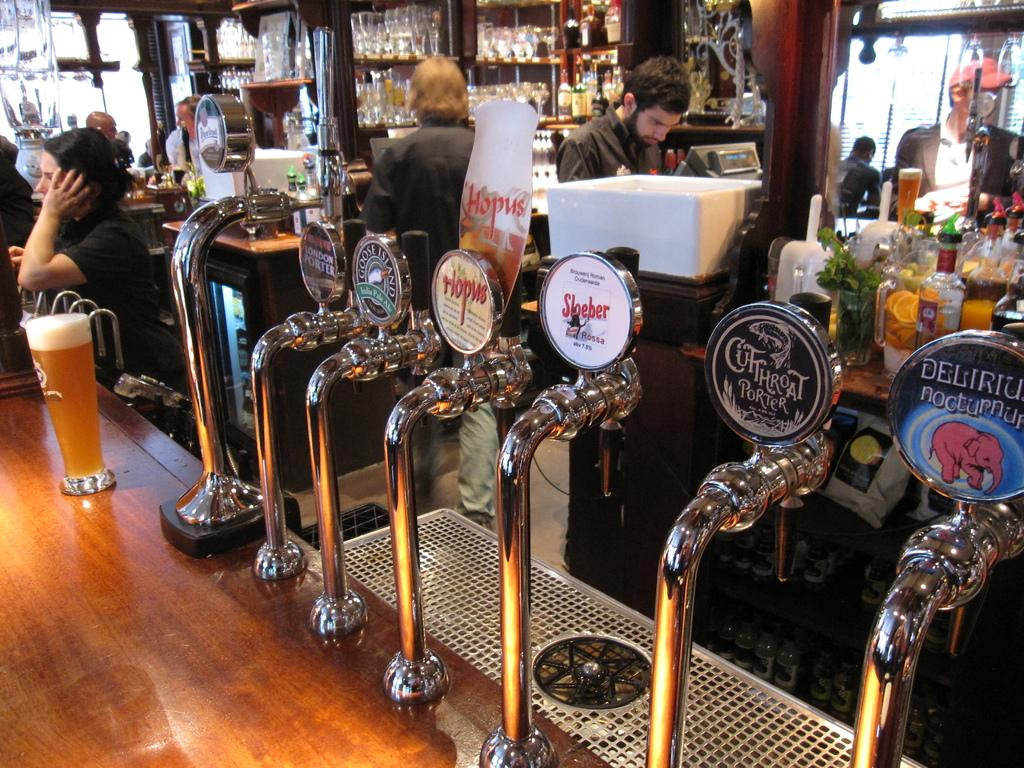<image>
Give a short and clear explanation of the subsequent image. A bar that shows seven beer spickets, one of them reads, Cutthroat Porter. 